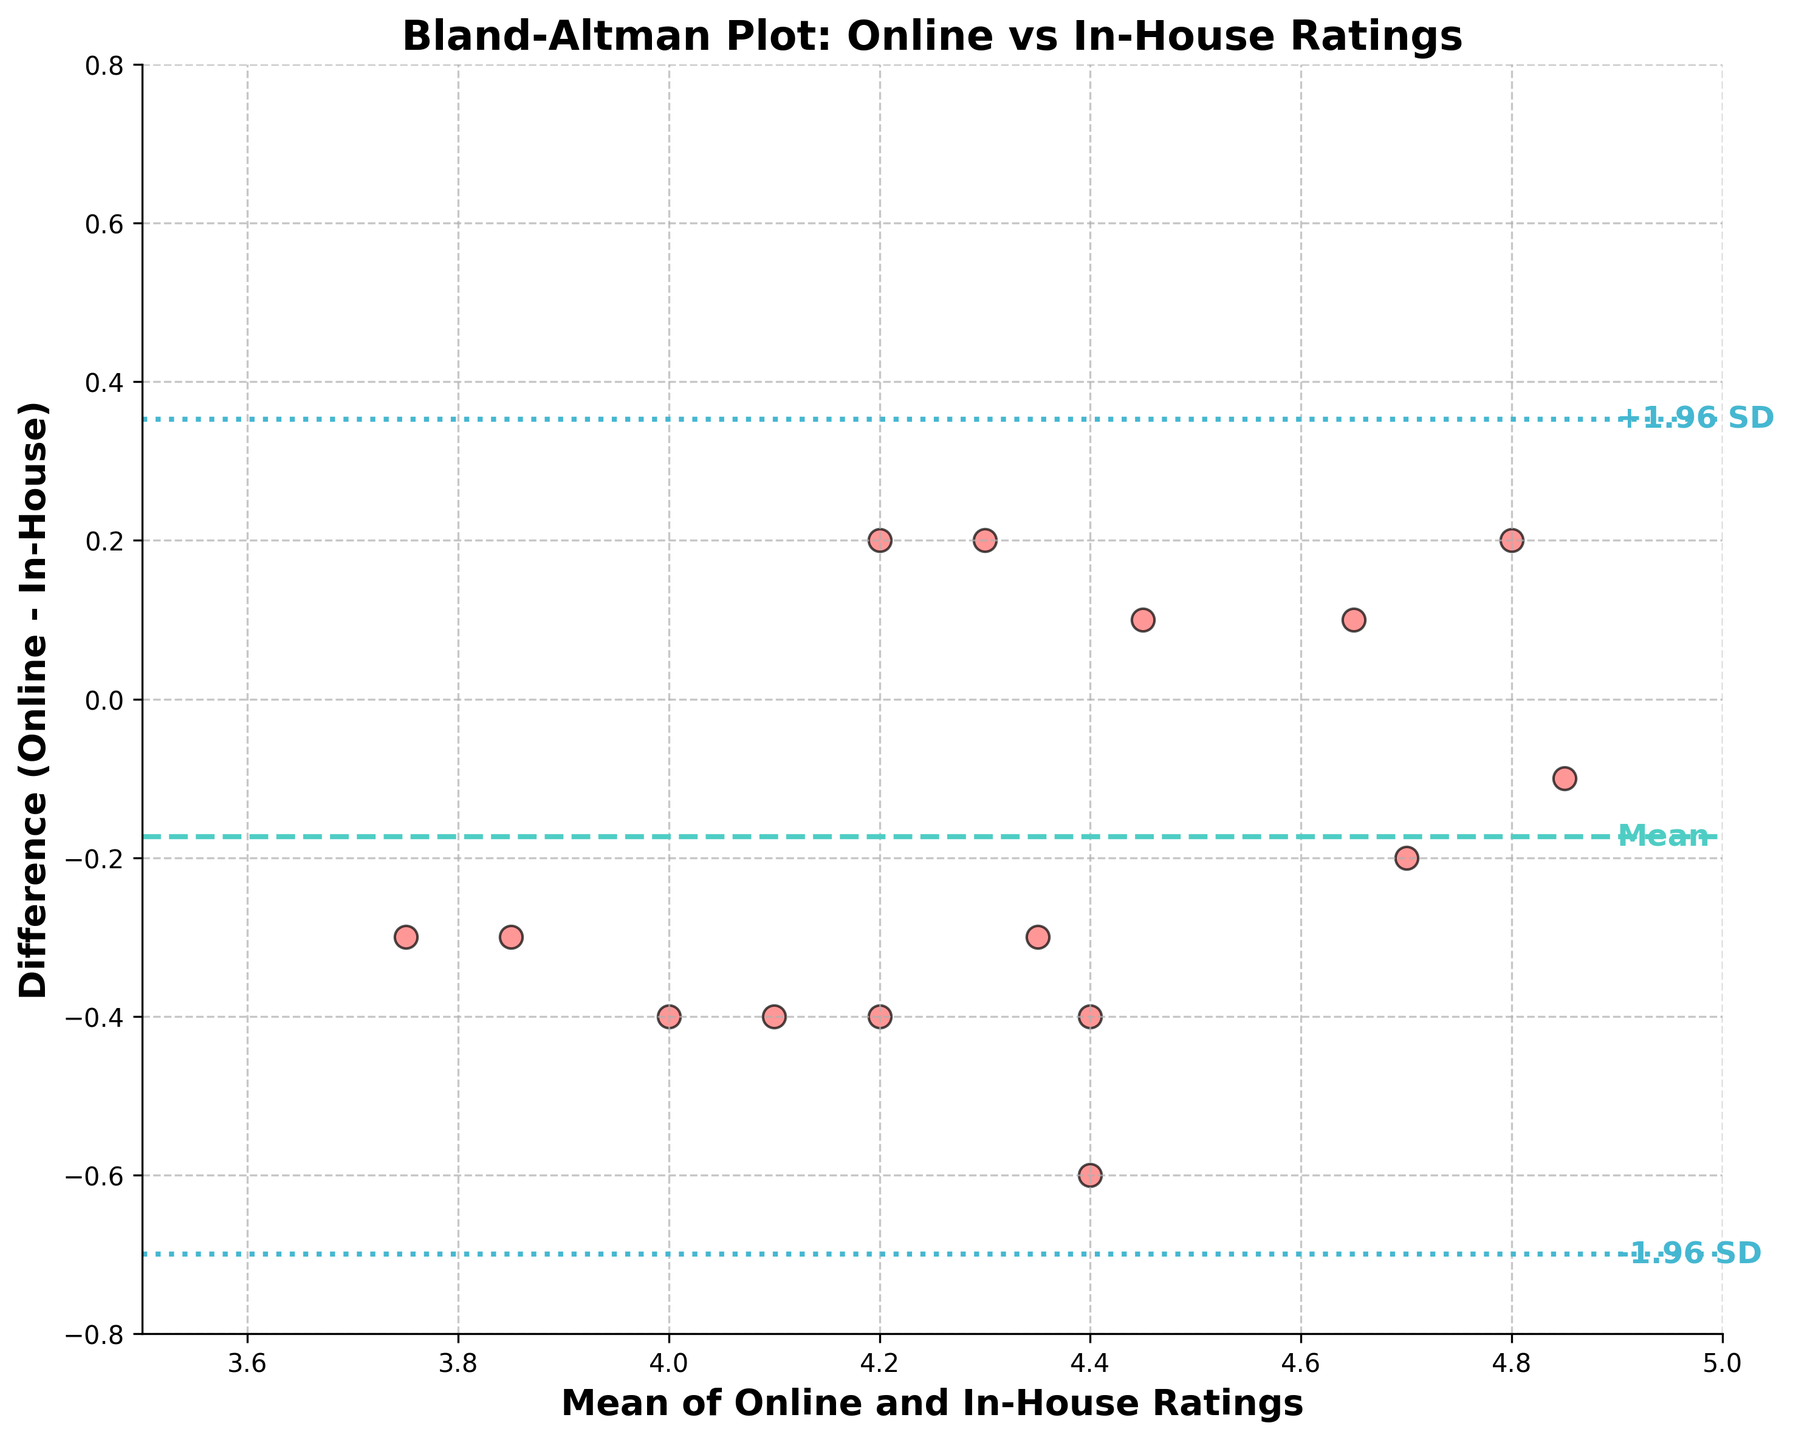What is the title of the plot? The title is located at the top of the plot. It reads "Bland-Altman Plot: Online vs In-House Ratings".
Answer: Bland-Altman Plot: Online vs In-House Ratings What does the x-axis represent? The x-axis has the label "Mean of Online and In-House Ratings". It represents the average value of the online and in-house ratings for each data point.
Answer: Mean of Online and In-House Ratings What are the y-axis limits? The y-axis limits are marked on either side of the plot. The minimum limit is -0.8 and the maximum limit is 0.8.
Answer: -0.8 to 0.8 How many data points are plotted in the graph? Each data point is represented by a red scatter on the plot. Counting the red dots gives a total of 15 data points.
Answer: 15 What color is used for the mean difference line? The mean difference line is represented by a dashed line and is colored in turquoise green (approximately #4ECDC4).
Answer: Turquoise green What are the limits of agreement in the plot? The plot includes two lines for limits of agreement, labeled as -1.96 SD and +1.96 SD. The lower limit of agreement is approximately -0.4 and the upper limit is about 0.4.
Answer: -0.4 to 0.4 Which data point has the largest difference between online and in-house ratings? The difference is calculated in the y-axis (Online Rating - In-House Rating). The point around (4.1, -0.6) has the largest negative difference, making its difference approximately -0.6.
Answer: Around (4.1, -0.6) How many data points fall outside the limits of agreement? Observing the plot, all data points fall between the two blue dashed lines representing the limits of agreement, so none fall outside.
Answer: 0 What is the mean difference between online and in-house ratings? The mean difference is visualized as the central dashed line (turquoise green) on the plot, positioned around 0.
Answer: Around 0 Are there more data points above or below the mean difference line? By comparing the data points above and below the mean difference line, there are more points below the line than above it.
Answer: Below 